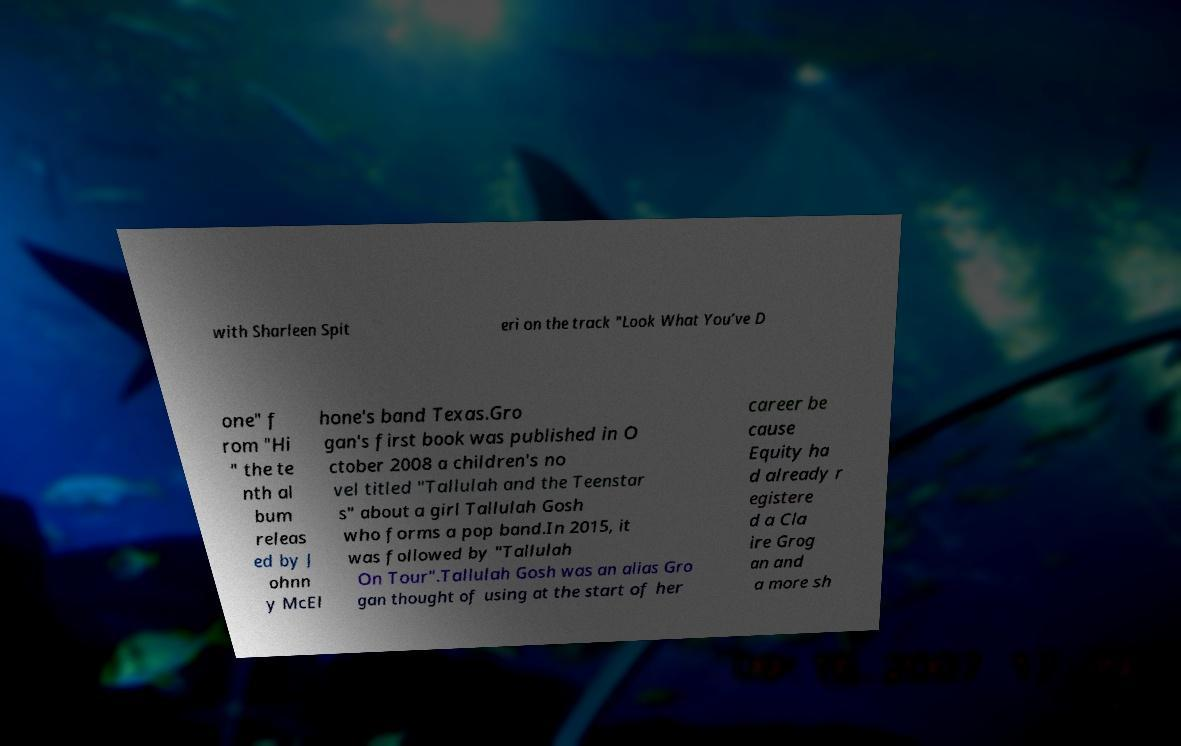Could you extract and type out the text from this image? with Sharleen Spit eri on the track "Look What You’ve D one" f rom "Hi " the te nth al bum releas ed by J ohnn y McEl hone's band Texas.Gro gan's first book was published in O ctober 2008 a children's no vel titled "Tallulah and the Teenstar s" about a girl Tallulah Gosh who forms a pop band.In 2015, it was followed by "Tallulah On Tour".Tallulah Gosh was an alias Gro gan thought of using at the start of her career be cause Equity ha d already r egistere d a Cla ire Grog an and a more sh 